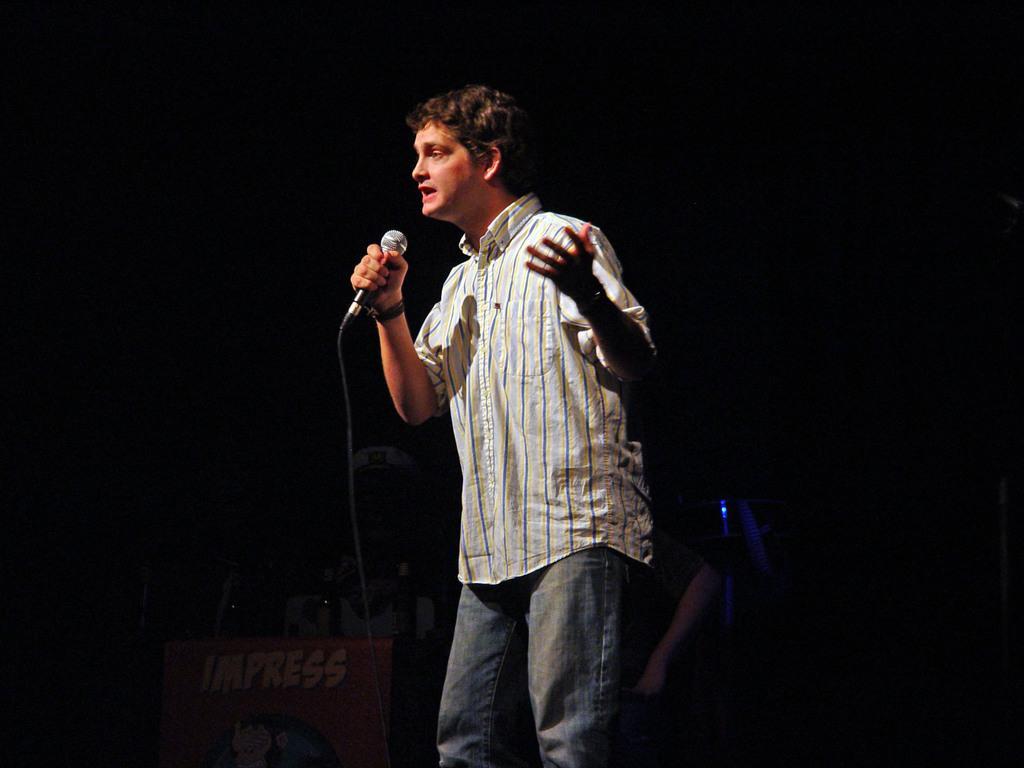Can you describe this image briefly? This is the picture of a man in white shirt holding a microphone and singing a song. Behind the man there is a wall. 